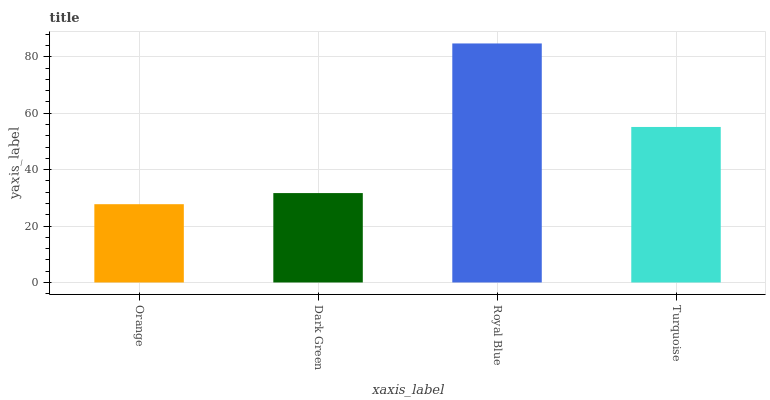Is Dark Green the minimum?
Answer yes or no. No. Is Dark Green the maximum?
Answer yes or no. No. Is Dark Green greater than Orange?
Answer yes or no. Yes. Is Orange less than Dark Green?
Answer yes or no. Yes. Is Orange greater than Dark Green?
Answer yes or no. No. Is Dark Green less than Orange?
Answer yes or no. No. Is Turquoise the high median?
Answer yes or no. Yes. Is Dark Green the low median?
Answer yes or no. Yes. Is Orange the high median?
Answer yes or no. No. Is Royal Blue the low median?
Answer yes or no. No. 